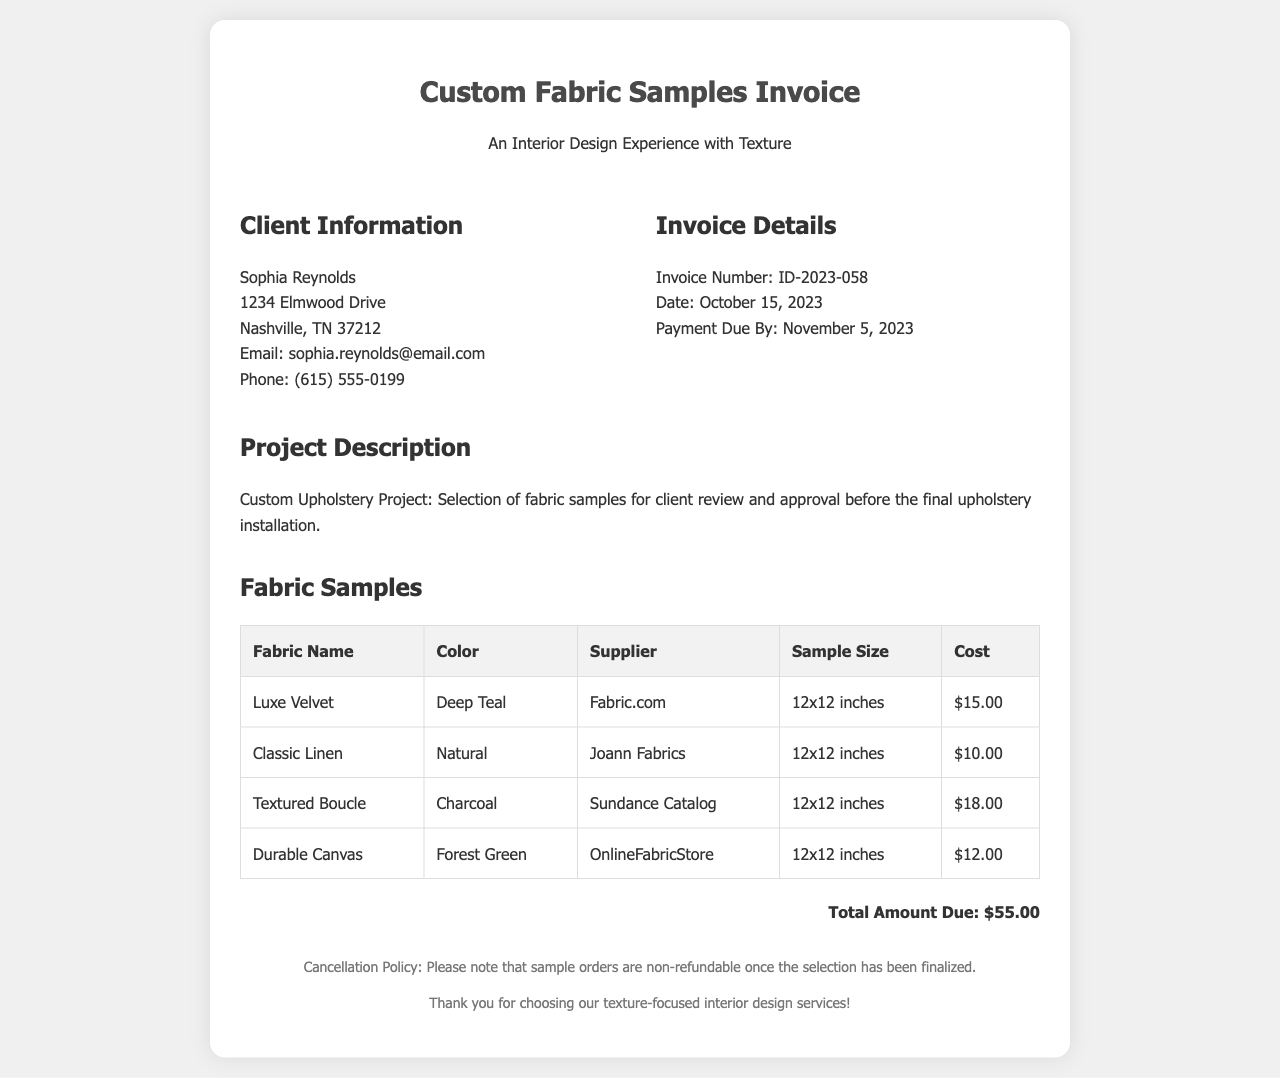What is the client's name? The client's name is included in the client information section of the document.
Answer: Sophia Reynolds What is the total amount due? The total amount due is clearly stated in the document.
Answer: $55.00 What is the invoice number? The invoice number can be found in the invoice details section.
Answer: ID-2023-058 When is the payment due by? The payment due date is provided in the invoice details section.
Answer: November 5, 2023 What is the fabric name for the second sample? The fabric names are listed in the fabric samples table.
Answer: Classic Linen What color is the Luxe Velvet fabric? The color of the Luxe Velvet fabric is specified in the fabric samples table.
Answer: Deep Teal How many fabric samples are listed? The number of fabric samples can be determined by counting the entries in the fabric samples table.
Answer: Four What is the cancellation policy for sample orders? The cancellation policy is mentioned in the footer section of the document.
Answer: Non-refundable once the selection has been finalized What supplier provides the Textured Boucle? The supplier's details are included in the fabric samples table.
Answer: Sundance Catalog 